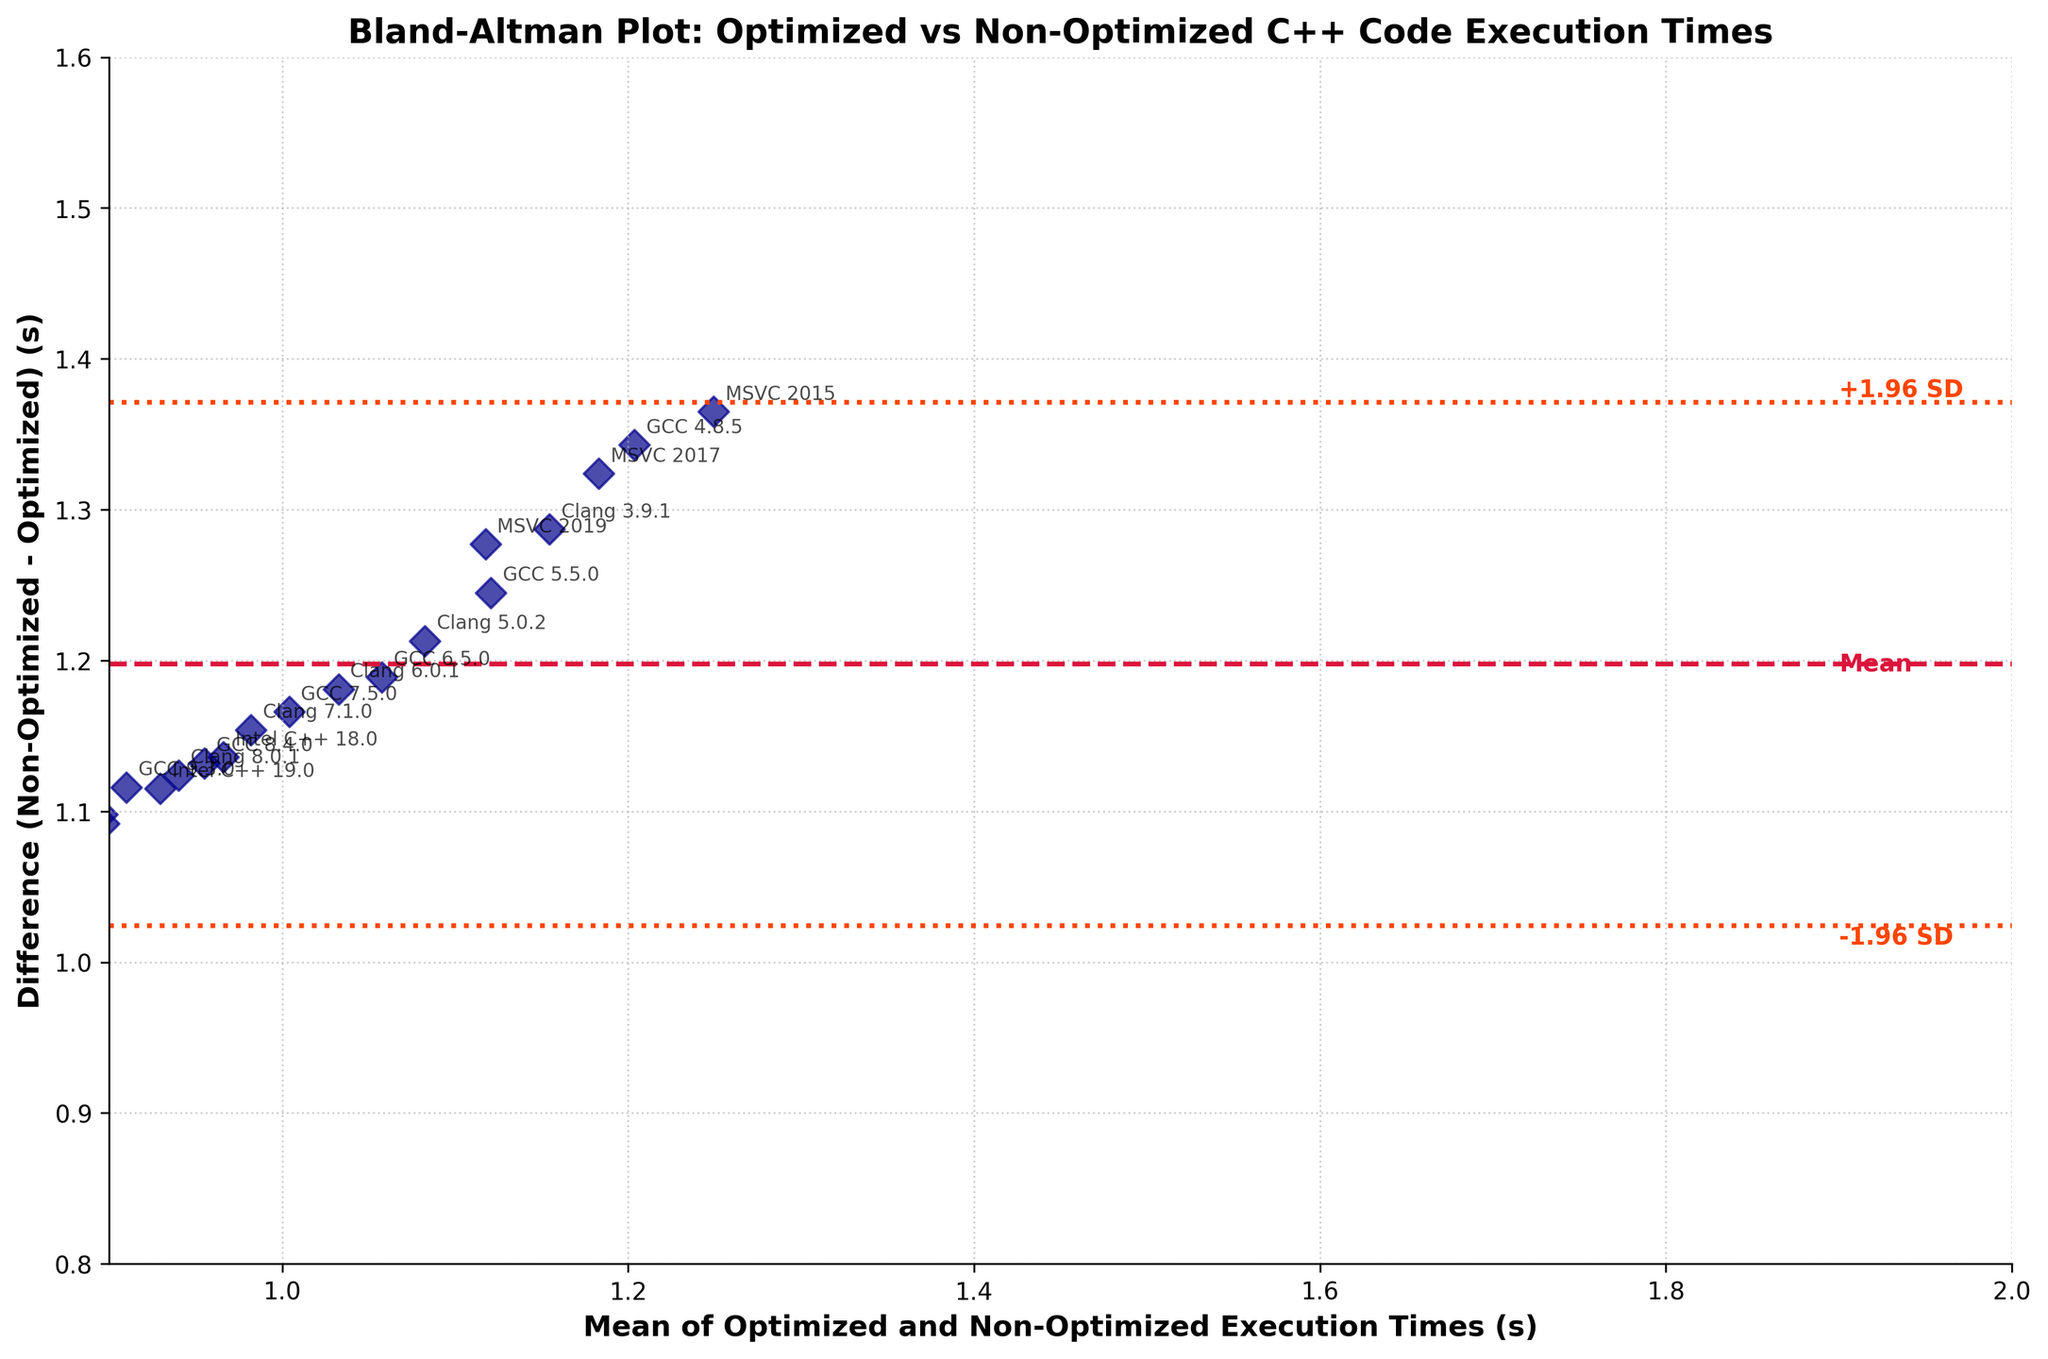What is the title of the plot? The title of the plot is found at the top. It is written in bold and provides an overall subject of the graph.
Answer: Bland-Altman Plot: Optimized vs Non-Optimized C++ Code Execution Times What do the x-axis and y-axis represent in the plot? The x-axis represents the mean of the optimized and non-optimized execution times, while the y-axis represents the difference between the non-optimized and optimized execution times.
Answer: x-axis: Mean of Optimized and Non-Optimized Execution Times (s), y-axis: Difference (Non-Optimized - Optimized) (s) How many compiler versions are compared in the plot? Each point in the plot represents a compiler version. Counting these points gives the number of compiler versions.
Answer: 17 What is the mean difference between the non-optimized and optimized execution times? The mean difference is indicated by the middle horizontal crimson dashed line in the plot. The text "Mean" is labeled next to this line.
Answer: Approximately 1.25s What are the limits of agreement in the plot? The limits of agreement are shown by the two orange-red dotted lines above and below the mean difference line. They represent mean ± 1.96 standard deviations.
Answer: Approximately 1.25s + 1.96 SD and 1.25s - 1.96 SD Which compiler shows the smallest mean execution time? The mean execution time is represented by the position on the x-axis. The compiler with the westernmost position on the x-axis has the smallest mean time.
Answer: Intel C++ 19.1 Which compiler shows the largest difference between non-optimized and optimized execution times? The difference between execution times is represented by the y-axis. The compiler with the highest point vertically has the largest difference.
Answer: MSVC 2015 Is there a compiler where the optimized and non-optimized times are closest? Look for the point closest to the x-axis (y=0), indicating similar execution times for optimized and non-optimized codes.
Answer: GCC 9.3.0 Compare the performance changes across all versions of GCC compilers. What trend do you observe? By observing the points representing the GCC compilers, note the positions in terms of mean and difference. Each version has a progressively lower difference and a leftward (lower mean times) placement.
Answer: Performance improves with each newer version of GCC What can be inferred about the variance in execution times from the plot? The spread of the differences along the vertical axis and the distance between the mean difference line and the limits of agreement lines indicate variance. More spread indicates higher variance.
Answer: There is significant variance in execution times between optimized and non-optimized codes 